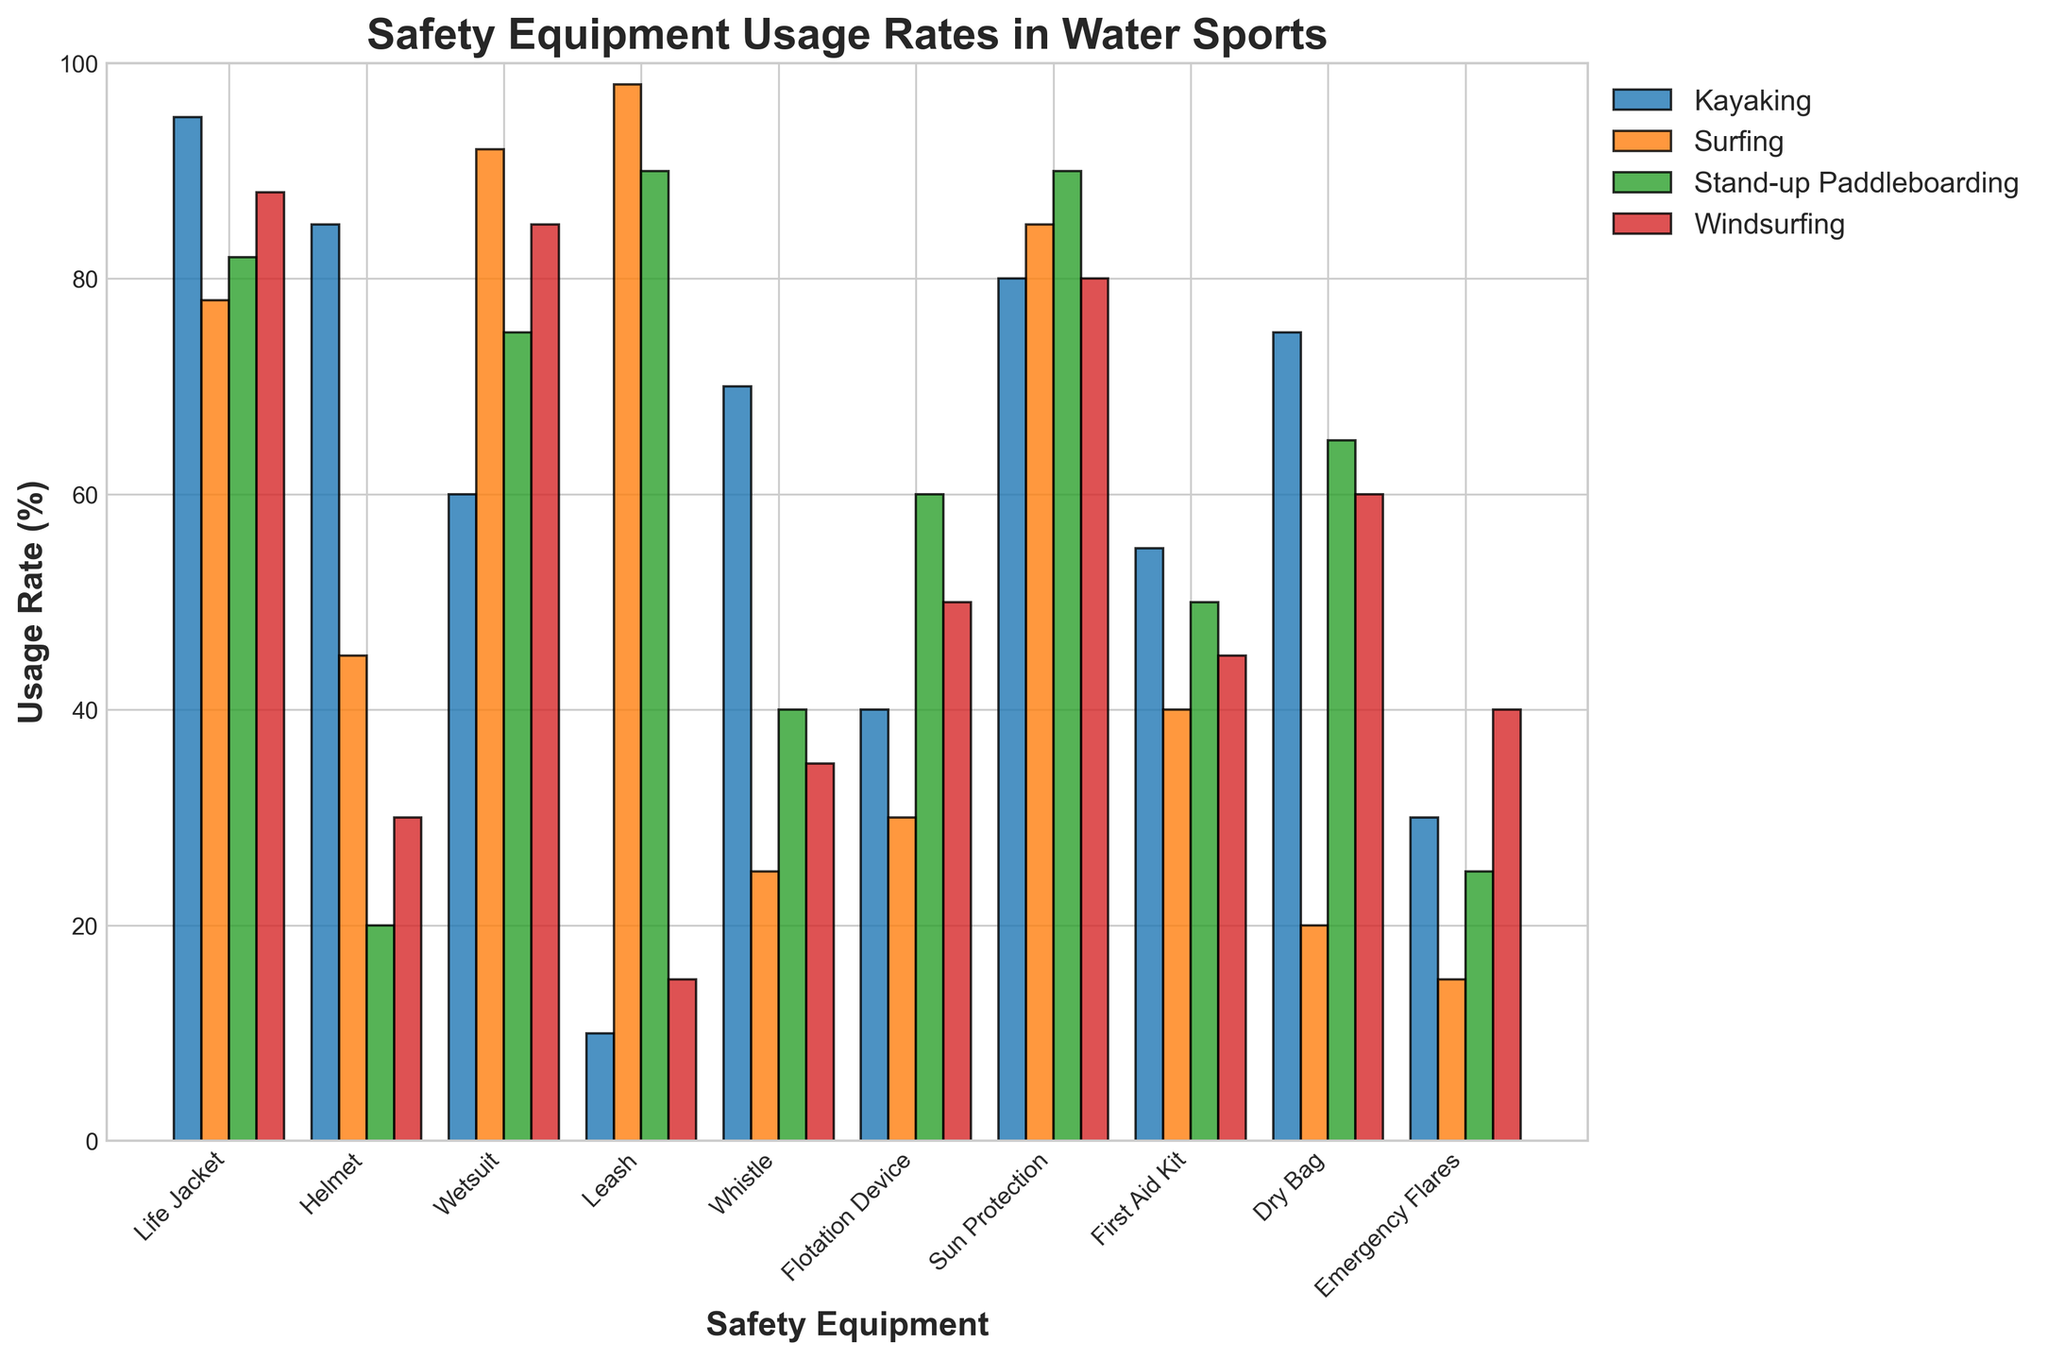Which sport has the highest usage rate of helmets? Observe the height of the helmet bars for each water sport. The kayaking bar is the highest.
Answer: Kayaking Which piece of equipment has the lowest usage rate in surfing? Examine the bars for each equipment category under surfing. The shortest bar is for emergency flares.
Answer: Emergency Flares Which sport uses life jackets the most, and which uses them the least? Compare the height of the life jacket bars across all sports. Kayaking has the highest bar, and surfing has the lowest.
Answer: Most: Kayaking, Least: Surfing How much higher is the usage rate of wetsuits in surfing compared to kayaking? Subtract the usage rate of wetsuits in kayaking from that in surfing (92 - 60).
Answer: 32% Which piece of equipment has a significantly higher usage rate in stand-up paddleboarding compared to windsurfing? Compare the bars for each equipment type between stand-up paddleboarding and windsurfing. Leash has a notably higher usage rate in stand-up paddleboarding.
Answer: Leash What is the average usage rate of dry bags across all sports? Add the usage rates of dry bags in all sports and divide by the number of sports (75 + 20 + 65 + 60) / 4.
Answer: 55% Which sport has more consistent usage rates across different types of equipment? Look at the bars' heights for each sport - windsurfing shows more even bars.
Answer: Windsurfing If you combine the usage rates of first aid kits and flares, in which sport is this combination the highest? Add the usage rates of first aid kits and flares for each sport, then compare. Kayaking has the highest combined rate (55 + 30).
Answer: Kayaking In which sport is the usage rate of sun protection equal to the usage rate of another piece of equipment? Identify equal bars within each sport. For windsurfing, sun protection and wetsuits both have a 80% usage rate.
Answer: Windsurfing Which item has a noticeably low usage rate in kayaking but is extensively used in surfing? Compare the bars for each equipment type between kayaking and surfing. Leash is low in kayaking and very high in surfing.
Answer: Leash 